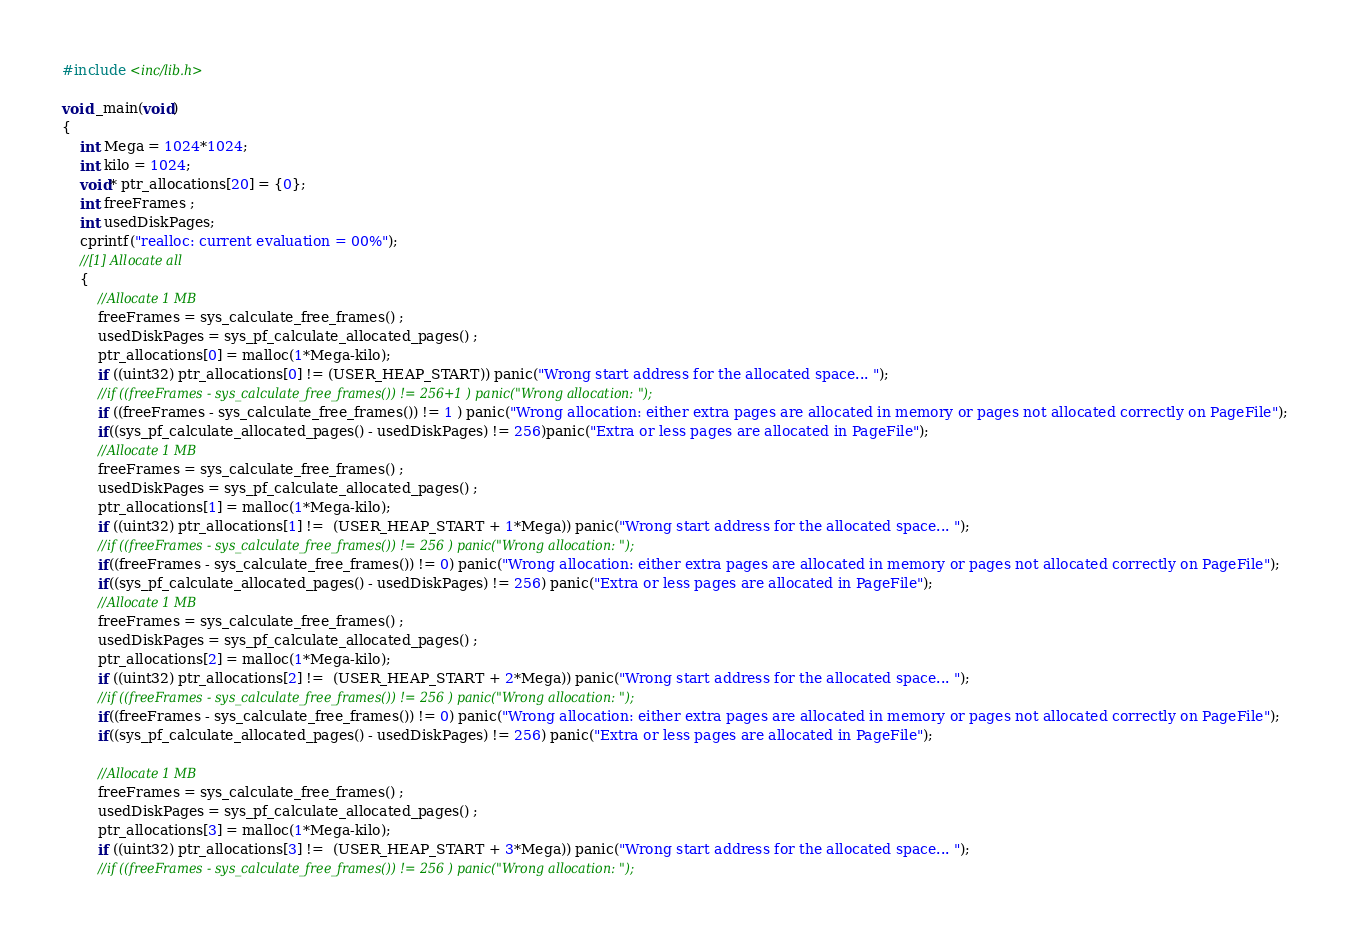<code> <loc_0><loc_0><loc_500><loc_500><_C_>#include <inc/lib.h>

void _main(void)
{
	int Mega = 1024*1024;
	int kilo = 1024;
	void* ptr_allocations[20] = {0};
	int freeFrames ;
	int usedDiskPages;
	cprintf("realloc: current evaluation = 00%");
	//[1] Allocate all
	{
		//Allocate 1 MB
		freeFrames = sys_calculate_free_frames() ;
		usedDiskPages = sys_pf_calculate_allocated_pages() ;
		ptr_allocations[0] = malloc(1*Mega-kilo);
		if ((uint32) ptr_allocations[0] != (USER_HEAP_START)) panic("Wrong start address for the allocated space... ");
		//if ((freeFrames - sys_calculate_free_frames()) != 256+1 ) panic("Wrong allocation: ");
		if ((freeFrames - sys_calculate_free_frames()) != 1 ) panic("Wrong allocation: either extra pages are allocated in memory or pages not allocated correctly on PageFile");
		if((sys_pf_calculate_allocated_pages() - usedDiskPages) != 256)panic("Extra or less pages are allocated in PageFile");
		//Allocate 1 MB
		freeFrames = sys_calculate_free_frames() ;
		usedDiskPages = sys_pf_calculate_allocated_pages() ;
		ptr_allocations[1] = malloc(1*Mega-kilo);
		if ((uint32) ptr_allocations[1] !=  (USER_HEAP_START + 1*Mega)) panic("Wrong start address for the allocated space... ");
		//if ((freeFrames - sys_calculate_free_frames()) != 256 ) panic("Wrong allocation: ");
		if((freeFrames - sys_calculate_free_frames()) != 0) panic("Wrong allocation: either extra pages are allocated in memory or pages not allocated correctly on PageFile");
		if((sys_pf_calculate_allocated_pages() - usedDiskPages) != 256) panic("Extra or less pages are allocated in PageFile");
		//Allocate 1 MB
		freeFrames = sys_calculate_free_frames() ;
		usedDiskPages = sys_pf_calculate_allocated_pages() ;
		ptr_allocations[2] = malloc(1*Mega-kilo);
		if ((uint32) ptr_allocations[2] !=  (USER_HEAP_START + 2*Mega)) panic("Wrong start address for the allocated space... ");
		//if ((freeFrames - sys_calculate_free_frames()) != 256 ) panic("Wrong allocation: ");
		if((freeFrames - sys_calculate_free_frames()) != 0) panic("Wrong allocation: either extra pages are allocated in memory or pages not allocated correctly on PageFile");
		if((sys_pf_calculate_allocated_pages() - usedDiskPages) != 256) panic("Extra or less pages are allocated in PageFile");

		//Allocate 1 MB
		freeFrames = sys_calculate_free_frames() ;
		usedDiskPages = sys_pf_calculate_allocated_pages() ;
		ptr_allocations[3] = malloc(1*Mega-kilo);
		if ((uint32) ptr_allocations[3] !=  (USER_HEAP_START + 3*Mega)) panic("Wrong start address for the allocated space... ");
		//if ((freeFrames - sys_calculate_free_frames()) != 256 ) panic("Wrong allocation: ");</code> 